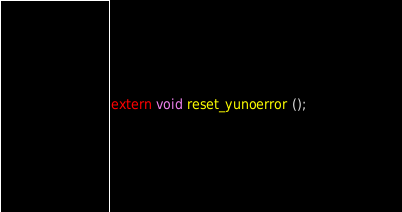Convert code to text. <code><loc_0><loc_0><loc_500><loc_500><_C_>
extern void reset_yunoerror ();
</code> 